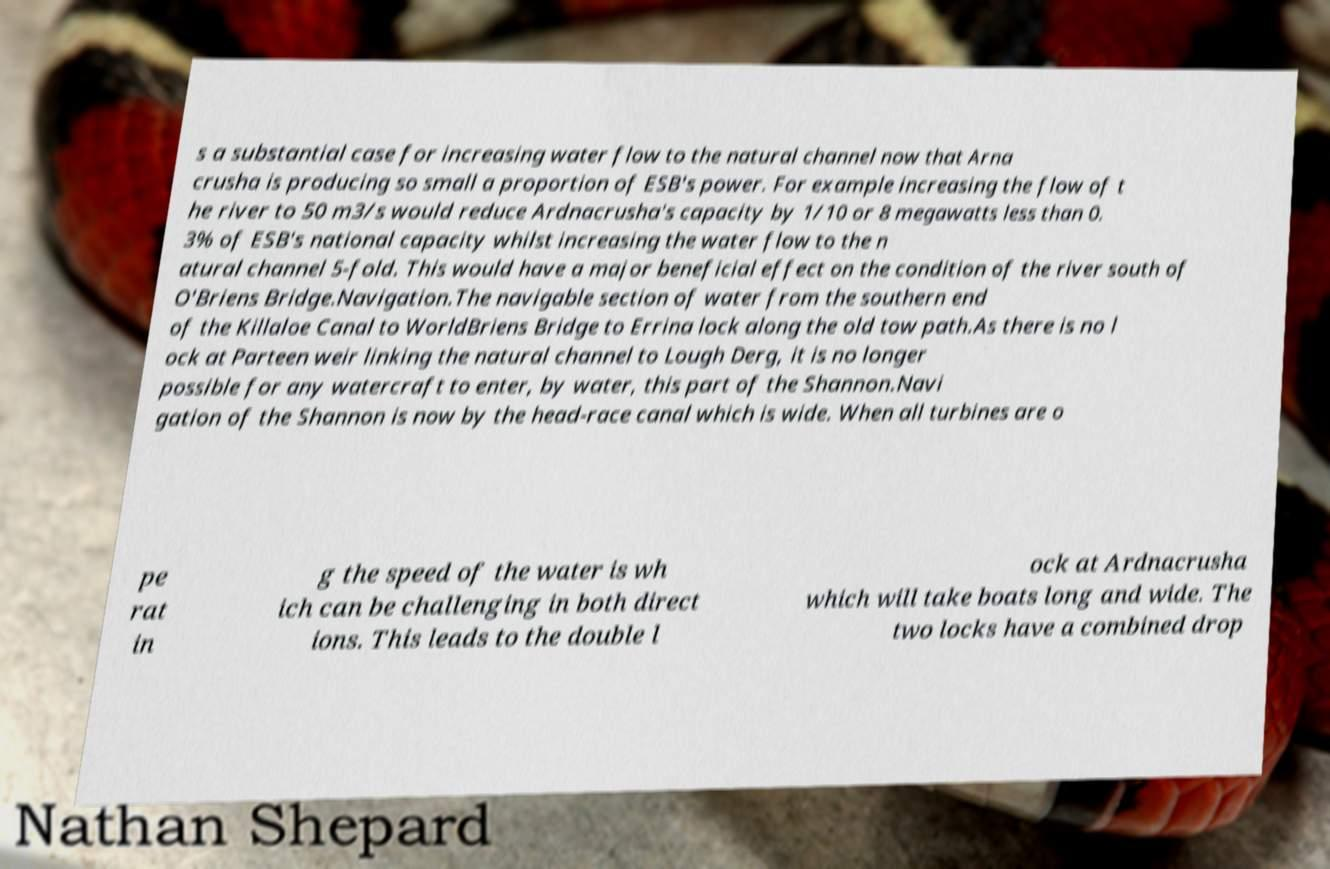There's text embedded in this image that I need extracted. Can you transcribe it verbatim? s a substantial case for increasing water flow to the natural channel now that Arna crusha is producing so small a proportion of ESB's power. For example increasing the flow of t he river to 50 m3/s would reduce Ardnacrusha's capacity by 1/10 or 8 megawatts less than 0. 3% of ESB's national capacity whilst increasing the water flow to the n atural channel 5-fold. This would have a major beneficial effect on the condition of the river south of O'Briens Bridge.Navigation.The navigable section of water from the southern end of the Killaloe Canal to WorldBriens Bridge to Errina lock along the old tow path.As there is no l ock at Parteen weir linking the natural channel to Lough Derg, it is no longer possible for any watercraft to enter, by water, this part of the Shannon.Navi gation of the Shannon is now by the head-race canal which is wide. When all turbines are o pe rat in g the speed of the water is wh ich can be challenging in both direct ions. This leads to the double l ock at Ardnacrusha which will take boats long and wide. The two locks have a combined drop 